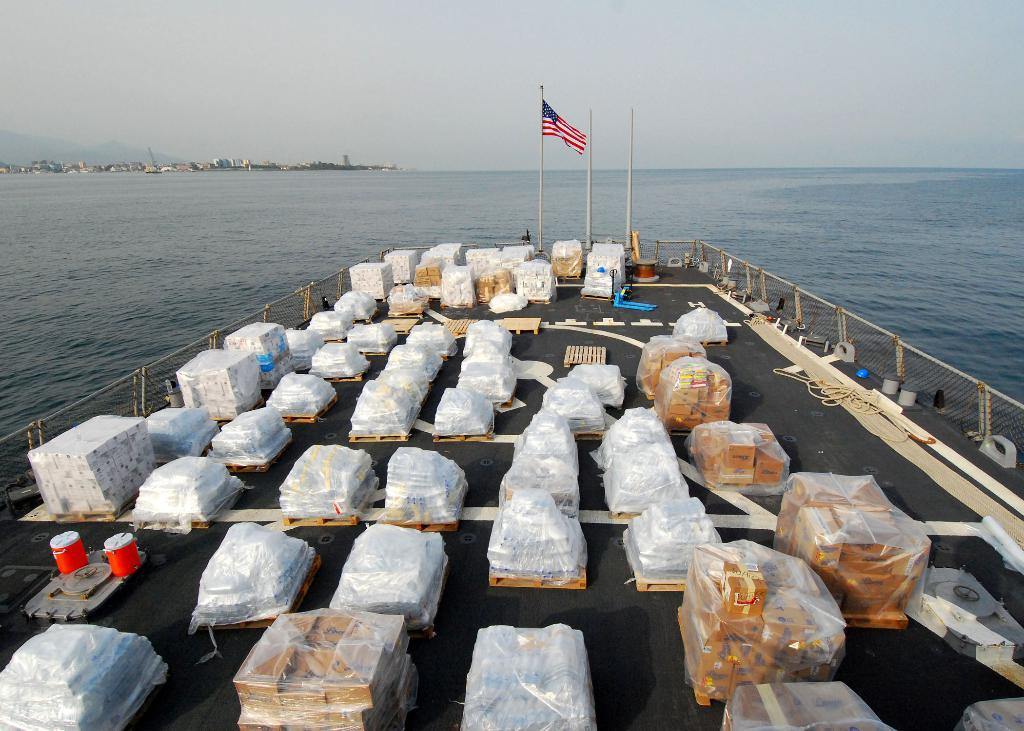What is the main subject of the image? The main subject of the image is a ship. Where is the ship located? The ship is on the water. What can be found inside the ship? There are objects in the ship. Are there any specific structures or features in the ship? Yes, there are poles in the ship. What other items can be seen in the ship? There is a rope and a flag in the ship. What is visible in the background of the image? Buildings, trees, and the sky are visible in the image. What type of linen is used to cover the ship's deck in the image? There is no mention of linen or any type of covering on the ship's deck in the image. How does the ship make you feel when looking at the image? The image does not convey any specific feelings or emotions; it is simply a depiction of a ship on the water. 